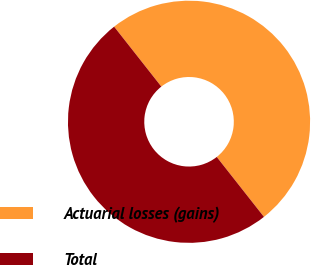Convert chart. <chart><loc_0><loc_0><loc_500><loc_500><pie_chart><fcel>Actuarial losses (gains)<fcel>Total<nl><fcel>50.0%<fcel>50.0%<nl></chart> 